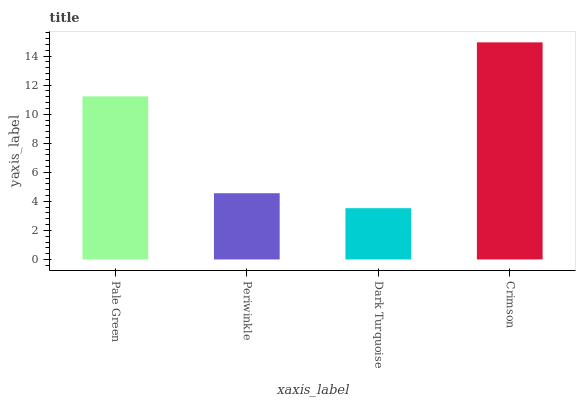Is Dark Turquoise the minimum?
Answer yes or no. Yes. Is Crimson the maximum?
Answer yes or no. Yes. Is Periwinkle the minimum?
Answer yes or no. No. Is Periwinkle the maximum?
Answer yes or no. No. Is Pale Green greater than Periwinkle?
Answer yes or no. Yes. Is Periwinkle less than Pale Green?
Answer yes or no. Yes. Is Periwinkle greater than Pale Green?
Answer yes or no. No. Is Pale Green less than Periwinkle?
Answer yes or no. No. Is Pale Green the high median?
Answer yes or no. Yes. Is Periwinkle the low median?
Answer yes or no. Yes. Is Dark Turquoise the high median?
Answer yes or no. No. Is Crimson the low median?
Answer yes or no. No. 